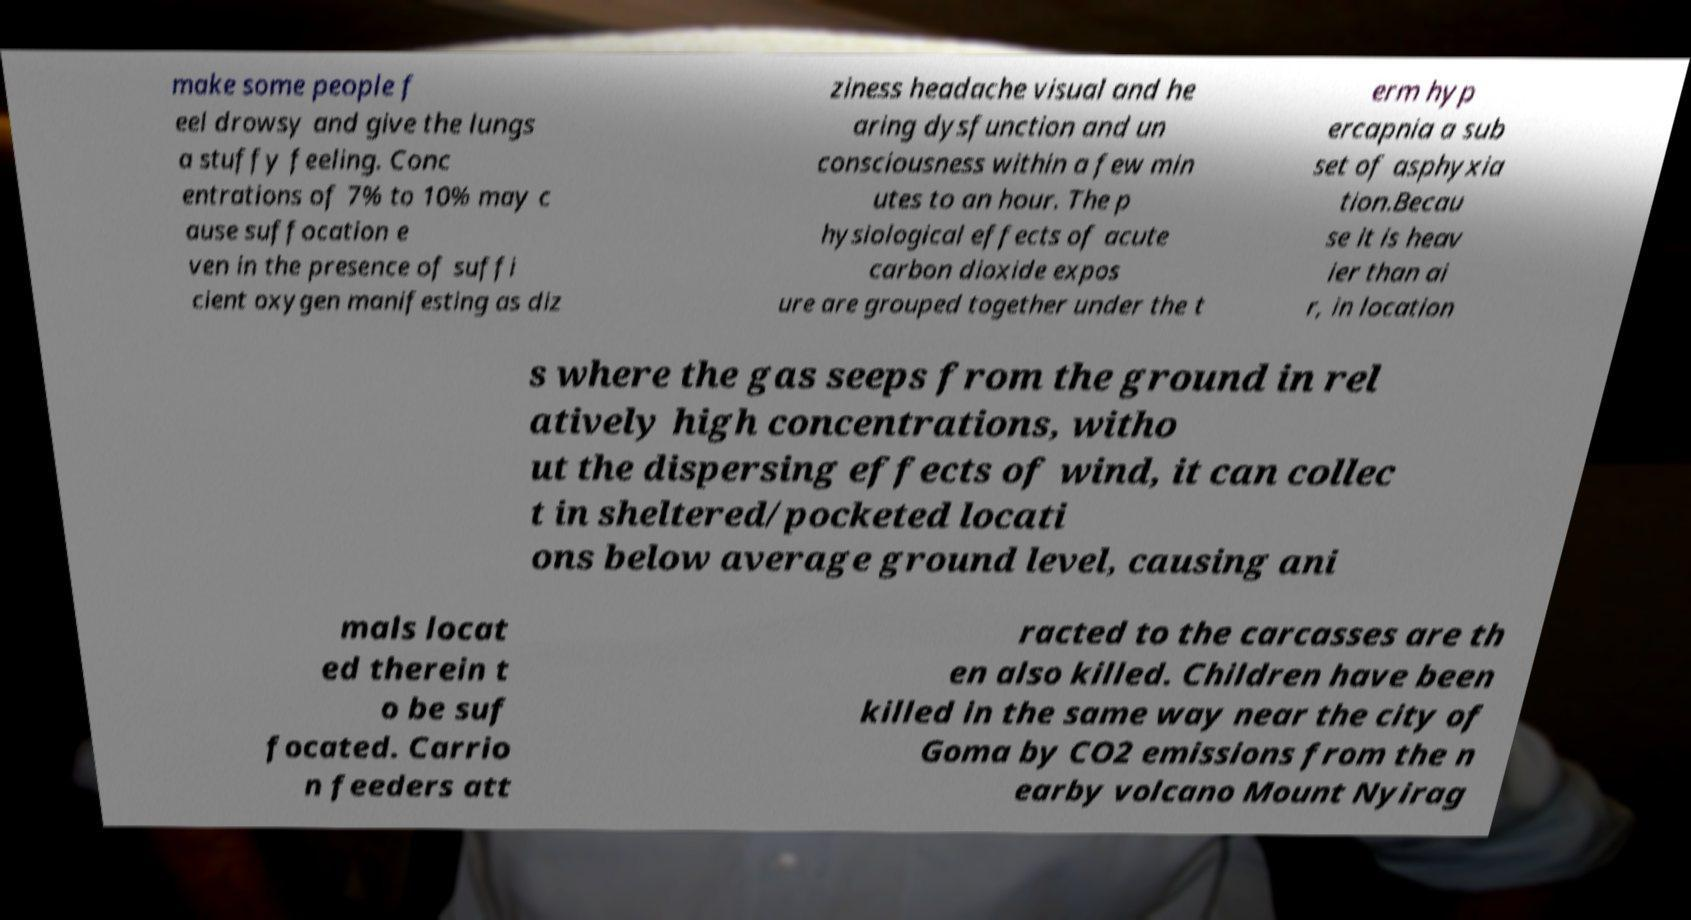Please identify and transcribe the text found in this image. make some people f eel drowsy and give the lungs a stuffy feeling. Conc entrations of 7% to 10% may c ause suffocation e ven in the presence of suffi cient oxygen manifesting as diz ziness headache visual and he aring dysfunction and un consciousness within a few min utes to an hour. The p hysiological effects of acute carbon dioxide expos ure are grouped together under the t erm hyp ercapnia a sub set of asphyxia tion.Becau se it is heav ier than ai r, in location s where the gas seeps from the ground in rel atively high concentrations, witho ut the dispersing effects of wind, it can collec t in sheltered/pocketed locati ons below average ground level, causing ani mals locat ed therein t o be suf focated. Carrio n feeders att racted to the carcasses are th en also killed. Children have been killed in the same way near the city of Goma by CO2 emissions from the n earby volcano Mount Nyirag 